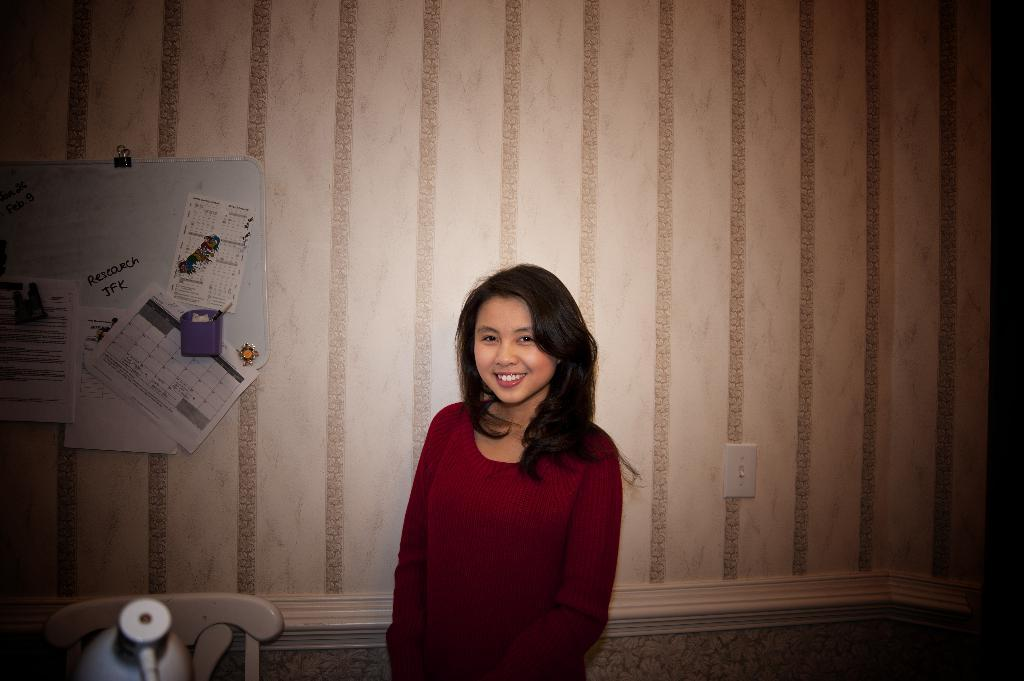What is the main subject in the image? There is a girl standing in the image. What objects can be seen in the foreground area of the image? There is a chair and a lamp in the foreground area of the image. What can be seen on the wall in the background of the image? Papers are present on the wall in the background of the image. What type of land is visible in the image? There is no land visible in the image; it is an indoor setting with a girl, chair, lamp, and papers on the wall. 